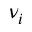<formula> <loc_0><loc_0><loc_500><loc_500>\nu _ { i }</formula> 